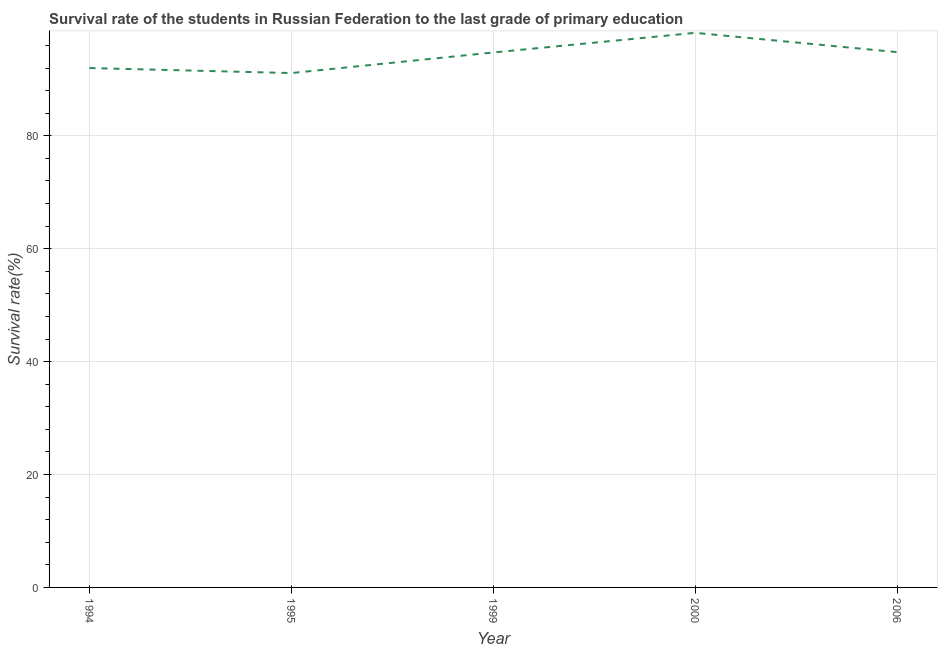What is the survival rate in primary education in 1999?
Make the answer very short. 94.76. Across all years, what is the maximum survival rate in primary education?
Offer a very short reply. 98.24. Across all years, what is the minimum survival rate in primary education?
Offer a very short reply. 91.11. What is the sum of the survival rate in primary education?
Give a very brief answer. 470.94. What is the difference between the survival rate in primary education in 1994 and 2006?
Offer a very short reply. -2.82. What is the average survival rate in primary education per year?
Ensure brevity in your answer.  94.19. What is the median survival rate in primary education?
Offer a very short reply. 94.76. Do a majority of the years between 1994 and 2000 (inclusive) have survival rate in primary education greater than 64 %?
Give a very brief answer. Yes. What is the ratio of the survival rate in primary education in 1995 to that in 2006?
Offer a terse response. 0.96. Is the difference between the survival rate in primary education in 1995 and 2006 greater than the difference between any two years?
Give a very brief answer. No. What is the difference between the highest and the second highest survival rate in primary education?
Offer a very short reply. 3.42. Is the sum of the survival rate in primary education in 1994 and 1995 greater than the maximum survival rate in primary education across all years?
Ensure brevity in your answer.  Yes. What is the difference between the highest and the lowest survival rate in primary education?
Ensure brevity in your answer.  7.13. Does the survival rate in primary education monotonically increase over the years?
Your answer should be very brief. No. How many lines are there?
Provide a succinct answer. 1. How many years are there in the graph?
Your response must be concise. 5. What is the difference between two consecutive major ticks on the Y-axis?
Give a very brief answer. 20. Does the graph contain any zero values?
Make the answer very short. No. What is the title of the graph?
Give a very brief answer. Survival rate of the students in Russian Federation to the last grade of primary education. What is the label or title of the X-axis?
Offer a very short reply. Year. What is the label or title of the Y-axis?
Provide a succinct answer. Survival rate(%). What is the Survival rate(%) of 1994?
Your response must be concise. 92.01. What is the Survival rate(%) of 1995?
Ensure brevity in your answer.  91.11. What is the Survival rate(%) of 1999?
Your response must be concise. 94.76. What is the Survival rate(%) of 2000?
Your response must be concise. 98.24. What is the Survival rate(%) in 2006?
Your response must be concise. 94.82. What is the difference between the Survival rate(%) in 1994 and 1995?
Your response must be concise. 0.89. What is the difference between the Survival rate(%) in 1994 and 1999?
Provide a succinct answer. -2.76. What is the difference between the Survival rate(%) in 1994 and 2000?
Provide a short and direct response. -6.23. What is the difference between the Survival rate(%) in 1994 and 2006?
Your response must be concise. -2.82. What is the difference between the Survival rate(%) in 1995 and 1999?
Provide a short and direct response. -3.65. What is the difference between the Survival rate(%) in 1995 and 2000?
Offer a terse response. -7.13. What is the difference between the Survival rate(%) in 1995 and 2006?
Offer a terse response. -3.71. What is the difference between the Survival rate(%) in 1999 and 2000?
Your response must be concise. -3.48. What is the difference between the Survival rate(%) in 1999 and 2006?
Provide a short and direct response. -0.06. What is the difference between the Survival rate(%) in 2000 and 2006?
Offer a terse response. 3.42. What is the ratio of the Survival rate(%) in 1994 to that in 2000?
Your answer should be compact. 0.94. What is the ratio of the Survival rate(%) in 1995 to that in 1999?
Provide a short and direct response. 0.96. What is the ratio of the Survival rate(%) in 1995 to that in 2000?
Provide a succinct answer. 0.93. What is the ratio of the Survival rate(%) in 1999 to that in 2000?
Provide a short and direct response. 0.96. What is the ratio of the Survival rate(%) in 1999 to that in 2006?
Offer a very short reply. 1. What is the ratio of the Survival rate(%) in 2000 to that in 2006?
Offer a terse response. 1.04. 